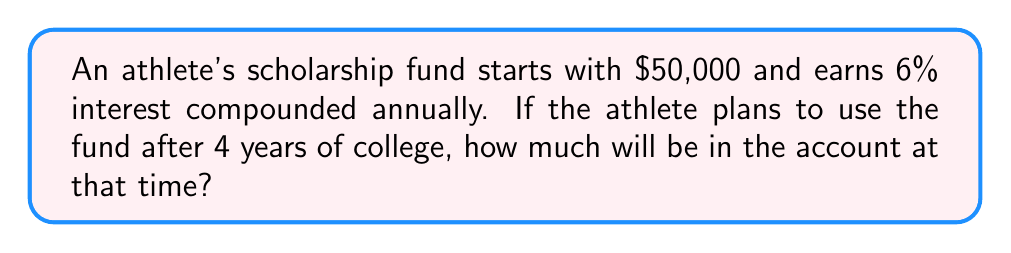What is the answer to this math problem? To solve this problem, we'll use the compound interest formula:

$$ A = P(1 + r)^n $$

Where:
$A$ = final amount
$P$ = principal (initial investment)
$r$ = annual interest rate (in decimal form)
$n$ = number of years

Given:
$P = \$50,000$
$r = 6\% = 0.06$
$n = 4$ years

Let's plug these values into the formula:

$$ A = 50,000(1 + 0.06)^4 $$

Now, let's solve step-by-step:

1) First, calculate $(1 + 0.06)^4$:
   $$ (1.06)^4 = 1.26247681 $$

2) Multiply this result by the principal:
   $$ 50,000 \times 1.26247681 = 63,123.8405 $$

3) Round to the nearest cent:
   $$ 63,123.84 $$

Therefore, after 4 years, the scholarship fund will grow to $63,123.84.
Answer: $63,123.84 